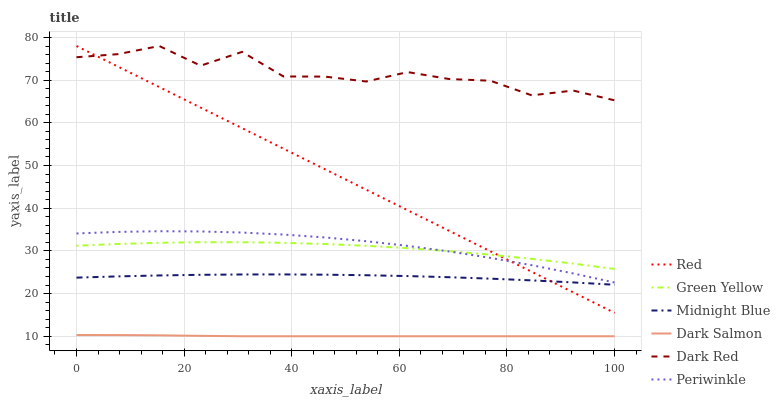Does Dark Salmon have the minimum area under the curve?
Answer yes or no. Yes. Does Dark Red have the maximum area under the curve?
Answer yes or no. Yes. Does Dark Red have the minimum area under the curve?
Answer yes or no. No. Does Dark Salmon have the maximum area under the curve?
Answer yes or no. No. Is Red the smoothest?
Answer yes or no. Yes. Is Dark Red the roughest?
Answer yes or no. Yes. Is Dark Salmon the smoothest?
Answer yes or no. No. Is Dark Salmon the roughest?
Answer yes or no. No. Does Dark Red have the lowest value?
Answer yes or no. No. Does Red have the highest value?
Answer yes or no. Yes. Does Dark Salmon have the highest value?
Answer yes or no. No. Is Midnight Blue less than Periwinkle?
Answer yes or no. Yes. Is Periwinkle greater than Midnight Blue?
Answer yes or no. Yes. Does Red intersect Dark Red?
Answer yes or no. Yes. Is Red less than Dark Red?
Answer yes or no. No. Is Red greater than Dark Red?
Answer yes or no. No. Does Midnight Blue intersect Periwinkle?
Answer yes or no. No. 